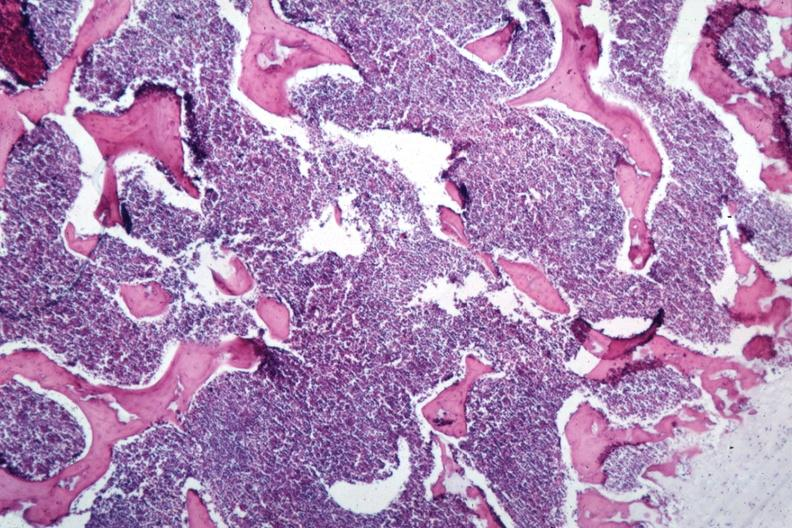what is present?
Answer the question using a single word or phrase. Bone marrow 